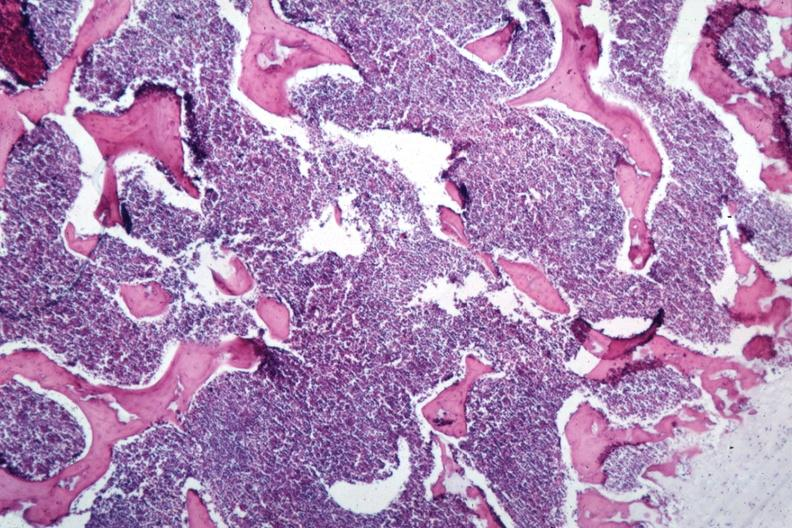what is present?
Answer the question using a single word or phrase. Bone marrow 